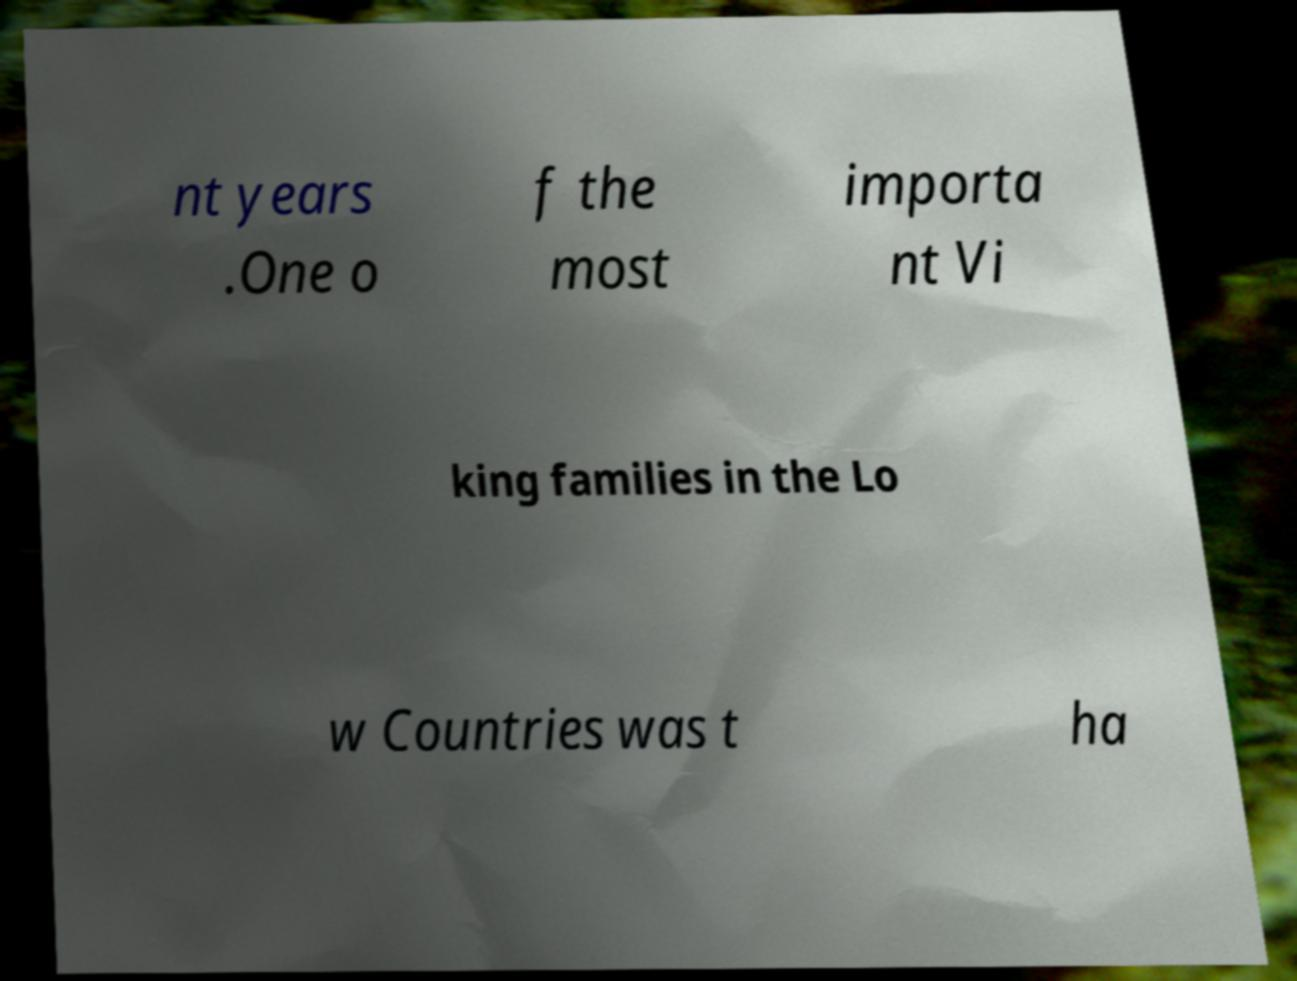Could you extract and type out the text from this image? nt years .One o f the most importa nt Vi king families in the Lo w Countries was t ha 